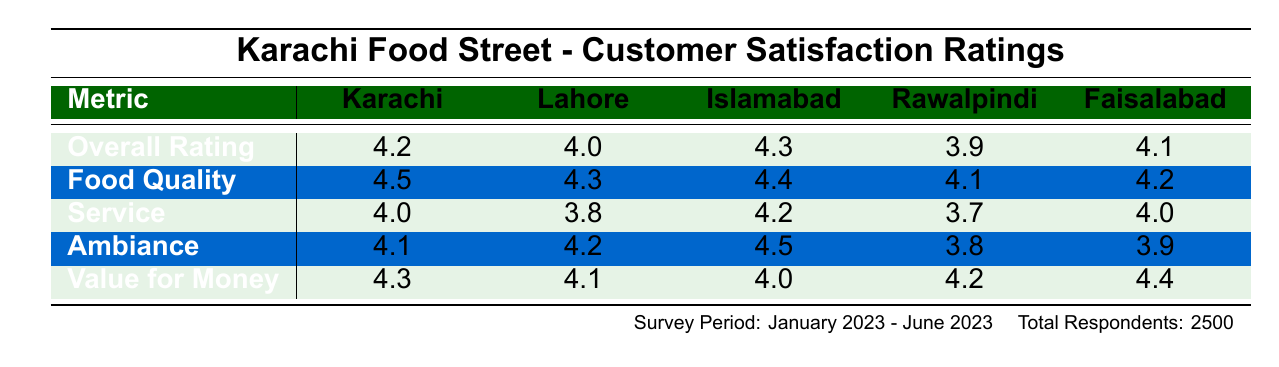What is the overall rating for the Lahore location? The table shows the overall rating for Lahore, which is listed directly as 4.0.
Answer: 4.0 Which location has the highest food quality rating? Looking at the food quality ratings, Islamabad has the highest score at 4.4 compared to the other locations.
Answer: Islamabad What is the difference in overall rating between Islamabad and Rawalpindi? Islamabad's overall rating is 4.3, while Rawalpindi's is 3.9. The difference is calculated as 4.3 - 3.9 = 0.4.
Answer: 0.4 Is the service rating in Faisalabad higher than in Lahore? The service rating for Faisalabad is 4.0 and for Lahore, it's 3.8. Since 4.0 is greater than 3.8, the statement is true.
Answer: Yes Which location has the lowest ambiance rating, and what is that rating? By examining the ambiance ratings, Rawalpindi has the lowest score at 3.8.
Answer: Rawalpindi, 3.8 Calculate the average value for money rating across all locations. The value for money ratings are 4.3 (Karachi), 4.1 (Lahore), 4.0 (Islamabad), 4.2 (Rawalpindi), and 4.4 (Faisalabad). To find the average, sum these values: 4.3 + 4.1 + 4.0 + 4.2 + 4.4 = 20.0, then divide by 5, resulting in 20.0/5 = 4.0.
Answer: 4.0 Which location has the highest overall rating, and what is it? Reviewing the overall ratings, Islamabad has the highest rating of 4.3.
Answer: Islamabad, 4.3 Is the food quality rating in Karachi greater than or equal to that in Faisalabad? Karachi's food quality rating is 4.5, and Faisalabad's is 4.2. Since 4.5 is greater than 4.2, the statement is true.
Answer: Yes If we sum the service ratings of all locations, what would be the total? The service ratings are 4.0 (Karachi), 3.8 (Lahore), 4.2 (Islamabad), 3.7 (Rawalpindi), and 4.0 (Faisalabad). Adding these gives 4.0 + 3.8 + 4.2 + 3.7 + 4.0 = 19.7.
Answer: 19.7 Which city has a lower value for money rating, Lahore or Rawalpindi? Lahore has a value for money rating of 4.1, while Rawalpindi's is 4.2. Since 4.1 is less than 4.2, Lahore has a lower rating.
Answer: Lahore 